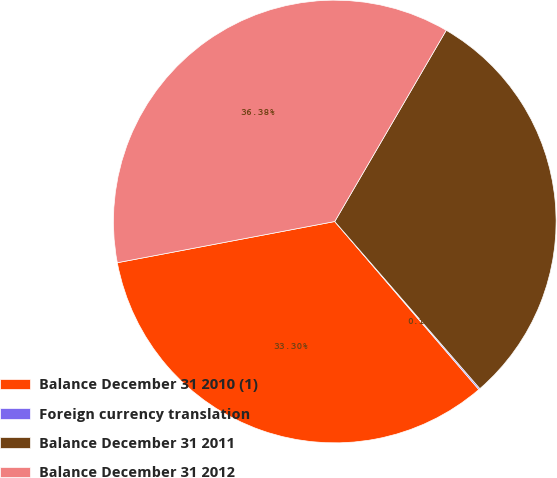Convert chart. <chart><loc_0><loc_0><loc_500><loc_500><pie_chart><fcel>Balance December 31 2010 (1)<fcel>Foreign currency translation<fcel>Balance December 31 2011<fcel>Balance December 31 2012<nl><fcel>33.3%<fcel>0.1%<fcel>30.22%<fcel>36.38%<nl></chart> 